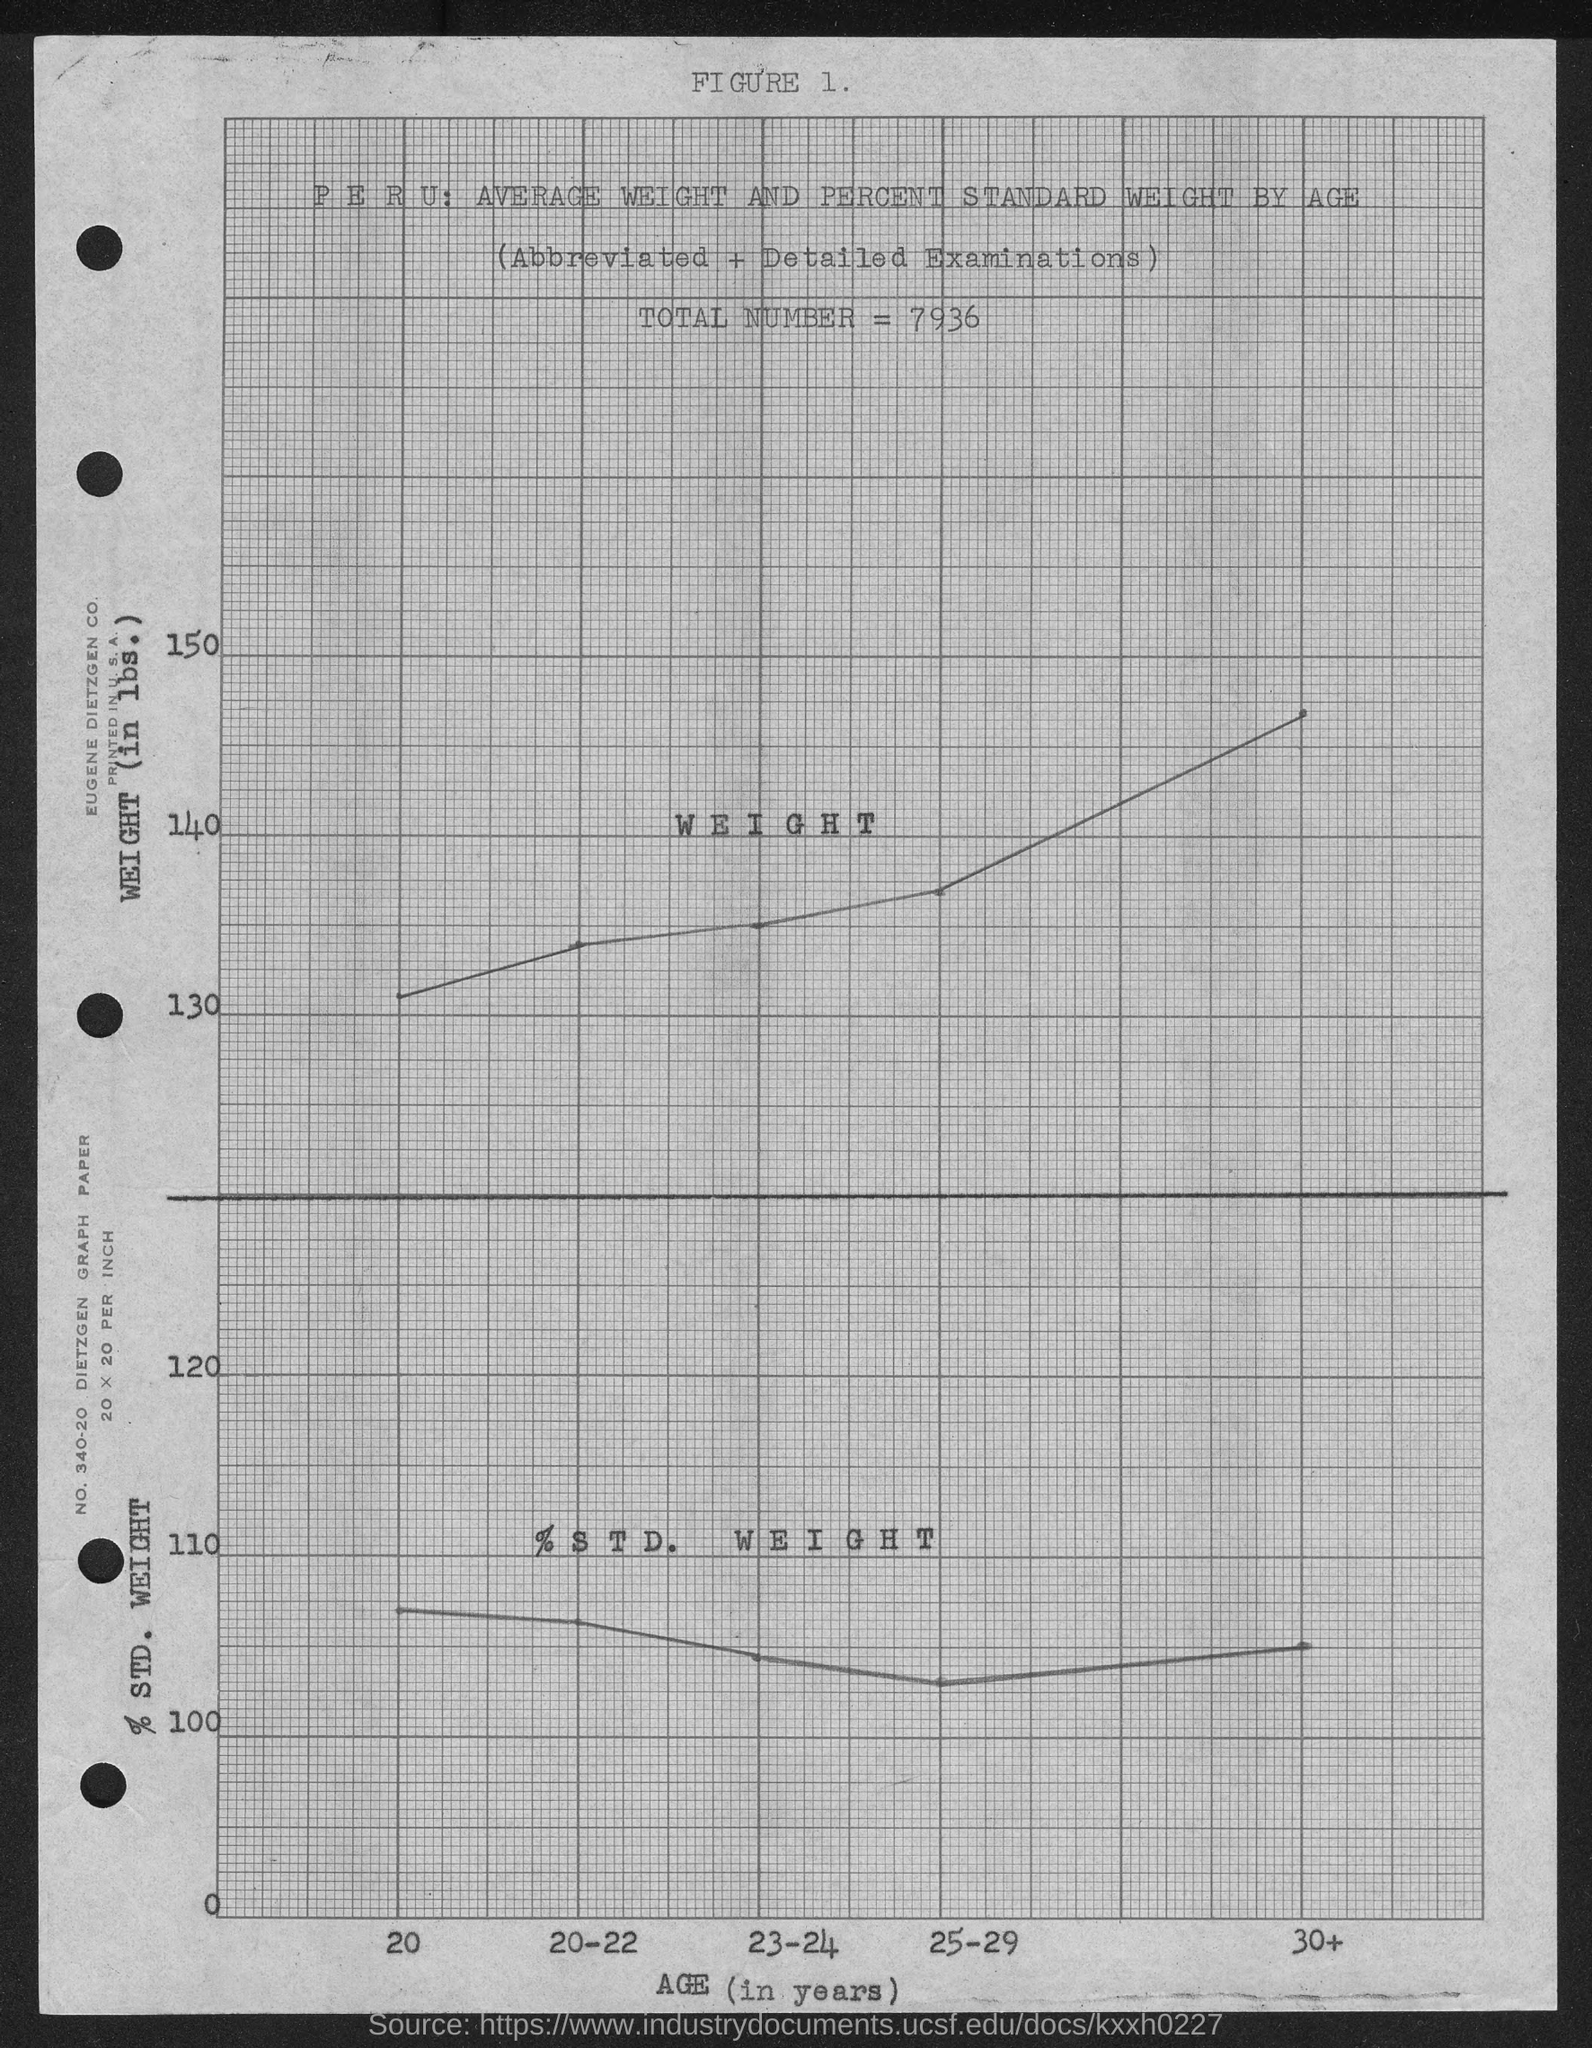What is the value of total number mentioned in the given graph ?
Ensure brevity in your answer.  7936. 